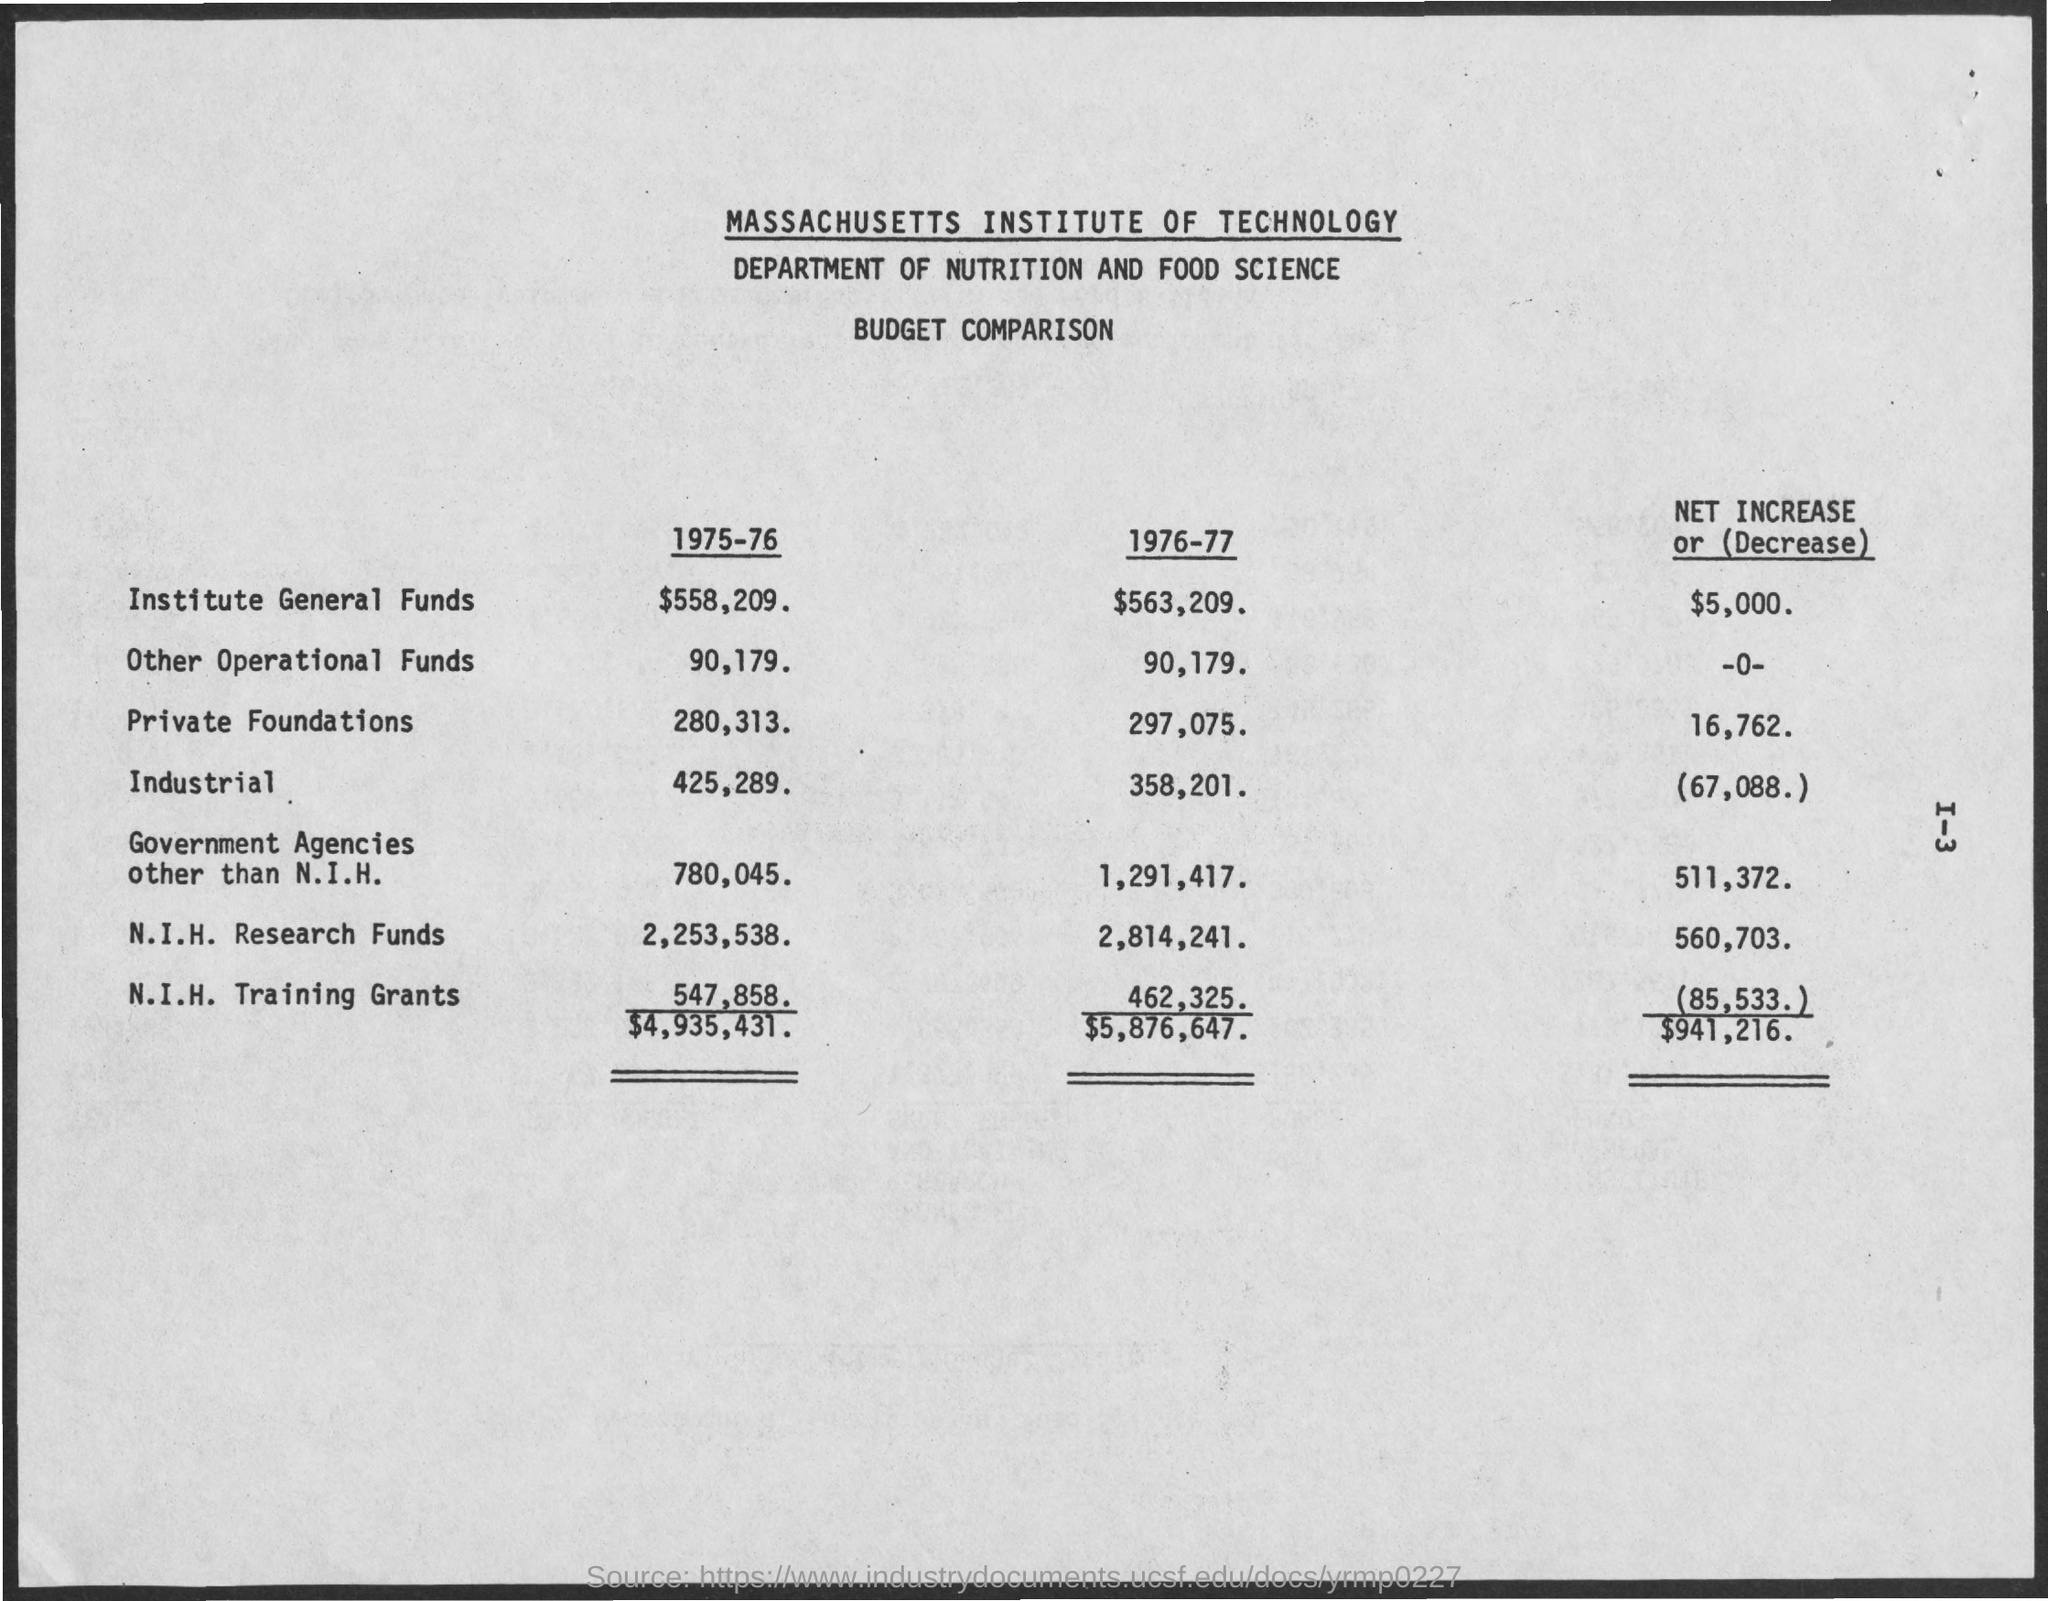What is the N.I.H. Research Funds for 1976-77?
 2,814,241 